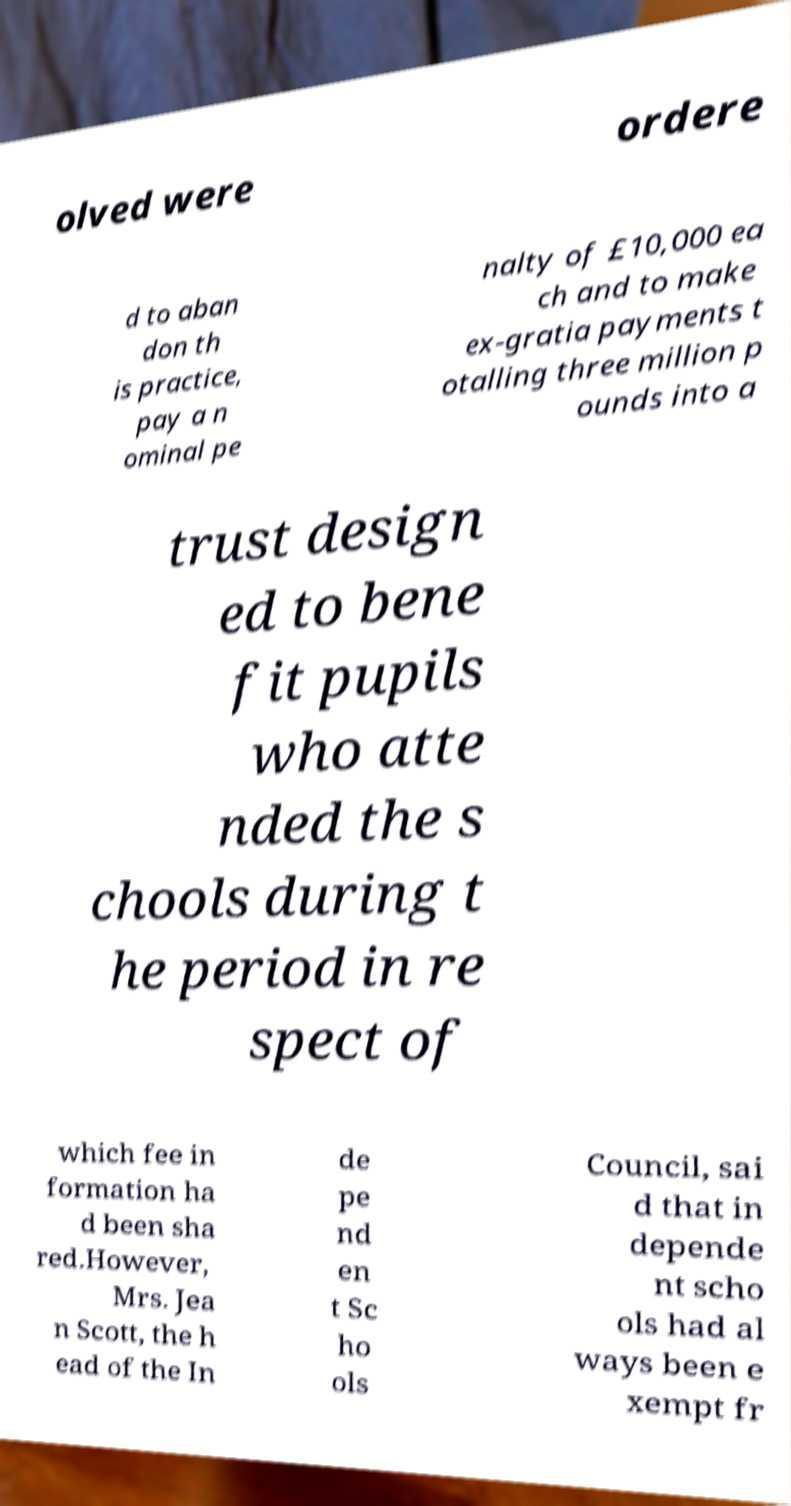For documentation purposes, I need the text within this image transcribed. Could you provide that? olved were ordere d to aban don th is practice, pay a n ominal pe nalty of £10,000 ea ch and to make ex-gratia payments t otalling three million p ounds into a trust design ed to bene fit pupils who atte nded the s chools during t he period in re spect of which fee in formation ha d been sha red.However, Mrs. Jea n Scott, the h ead of the In de pe nd en t Sc ho ols Council, sai d that in depende nt scho ols had al ways been e xempt fr 